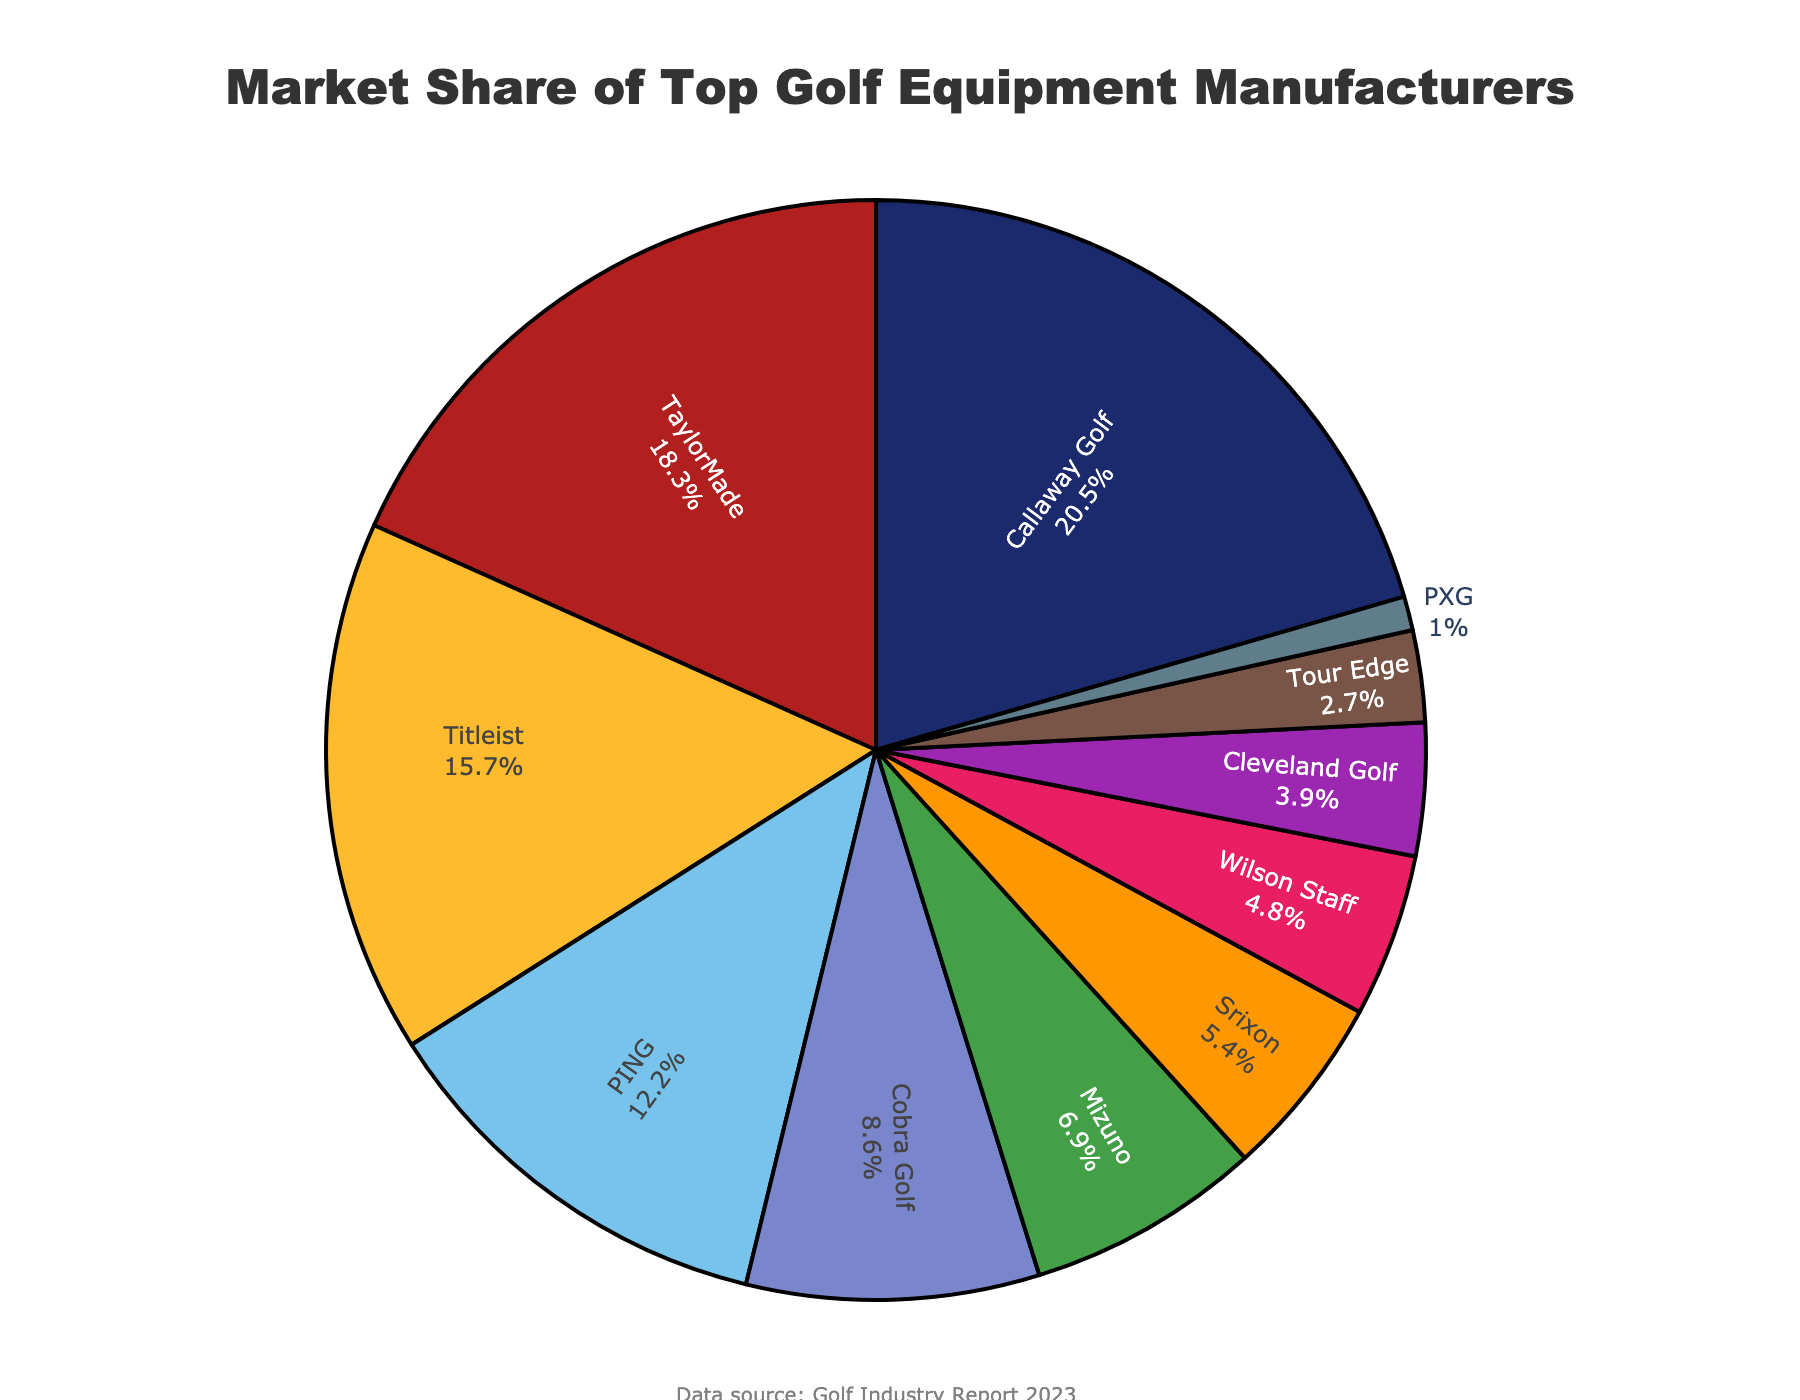What is the market share of Callaway Golf? Refer to the figure and locate the segment labeled "Callaway Golf" in the pie chart, which shows 20.5%.
Answer: 20.5% Which company has the smallest market share? Identify the smallest segment in the pie chart, which is labeled "PXG" with 1.0%.
Answer: PXG What is the combined market share of Titleist and PING? Locate the market shares for Titleist (15.7%) and PING (12.2%) in the figure, then sum them: 15.7 + 12.2 = 27.9%.
Answer: 27.9% How does the market share of TaylorMade compare to Cobra Golf? TaylorMade has 18.3% market share, while Cobra Golf has 8.6%. Since 18.3% is greater than 8.6%, TaylorMade has a larger market share than Cobra Golf.
Answer: TaylorMade has a larger market share What is the average market share of the three companies with the highest market shares? Identify the top three companies: Callaway Golf (20.5%), TaylorMade (18.3%), and Titleist (15.7%). Calculate the average: (20.5 + 18.3 + 15.7) / 3 = 54.5 / 3 ≈ 18.17%.
Answer: 18.17% Which two companies have a market share that, when combined, is exactly 10% or closest to 10%? Compare possible combinations: Mizuno (6.9%) and Wilson Staff (4.8%) sum to 11.7%; Wilson Staff (4.8%) and Srixon (5.4%) sum to 10.2%; Cleveland Golf (3.9%) and Tour Edge (2.7%) sum to 6.6%, etc. The closest combination to 10% is Srixon and Wilson Staff with 10.2%.
Answer: Srixon and Wilson Staff What fraction of the market is dominated by the top four companies? Add the market shares of Callaway Golf (20.5%), TaylorMade (18.3%), Titleist (15.7%), and PING (12.2%): 20.5 + 18.3 + 15.7 + 12.2 = 66.7%. Hence, the fraction is 66.7/100 = 0.667.
Answer: 0.667 How much more market share does Callaway Golf have compared to Tour Edge? Subtract Tour Edge's market share (2.7%) from Callaway Golf's (20.5%): 20.5 - 2.7 = 17.8%.
Answer: 17.8% Which company represented by a green segment has a higher market share, PING or Srixon? In the chart, PING and Srixon segments use green shades; PING has 12.2%, and Srixon has 5.4%. As 12.2% is greater than 5.4%, PING has a higher market share.
Answer: PING 